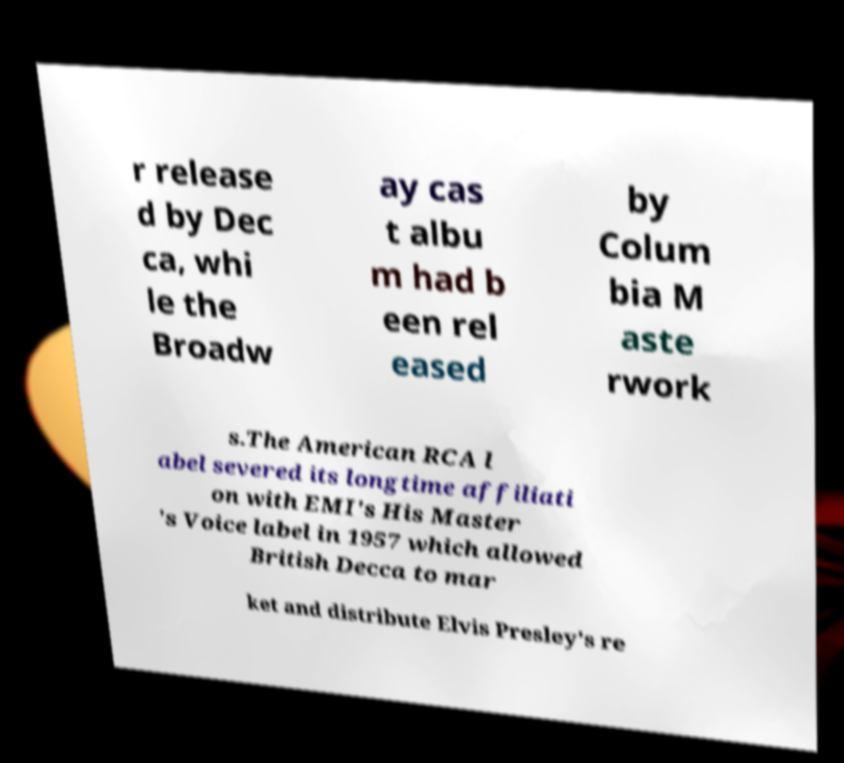Can you accurately transcribe the text from the provided image for me? r release d by Dec ca, whi le the Broadw ay cas t albu m had b een rel eased by Colum bia M aste rwork s.The American RCA l abel severed its longtime affiliati on with EMI's His Master 's Voice label in 1957 which allowed British Decca to mar ket and distribute Elvis Presley's re 